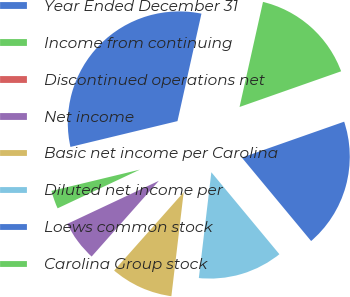Convert chart to OTSL. <chart><loc_0><loc_0><loc_500><loc_500><pie_chart><fcel>Year Ended December 31<fcel>Income from continuing<fcel>Discontinued operations net<fcel>Net income<fcel>Basic net income per Carolina<fcel>Diluted net income per<fcel>Loews common stock<fcel>Carolina Group stock<nl><fcel>32.26%<fcel>3.23%<fcel>0.0%<fcel>6.45%<fcel>9.68%<fcel>12.9%<fcel>19.35%<fcel>16.13%<nl></chart> 